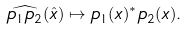Convert formula to latex. <formula><loc_0><loc_0><loc_500><loc_500>\widehat { p _ { 1 } p _ { 2 } } ( \hat { x } ) \mapsto p _ { 1 } ( x ) ^ { * } p _ { 2 } ( x ) .</formula> 